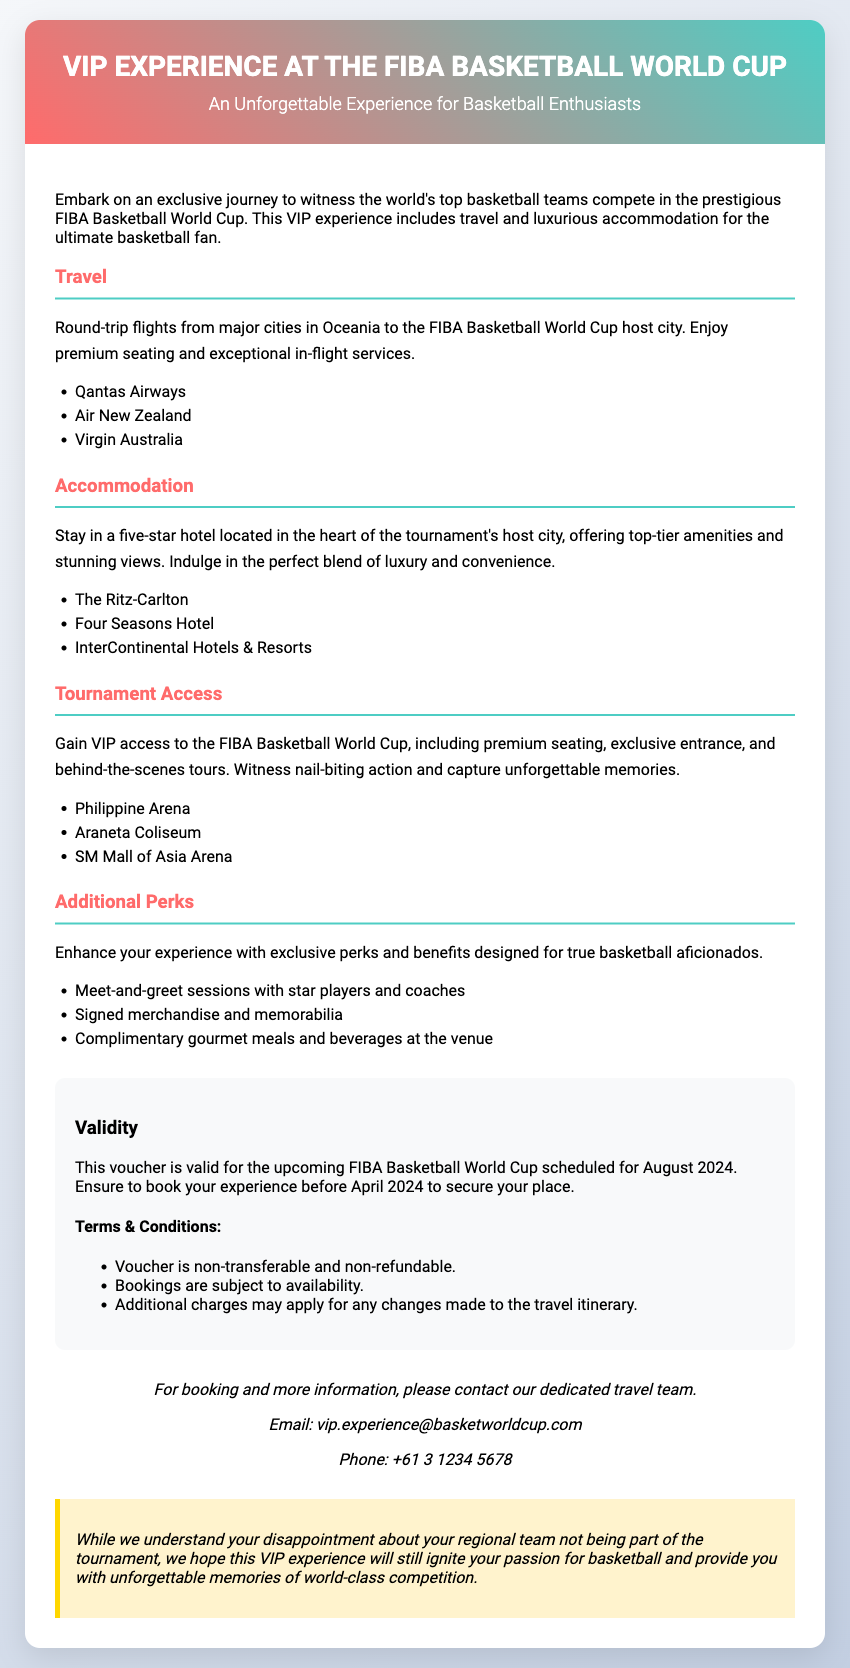what is the title of the VIP experience? The title of the VIP experience is prominently displayed at the top of the document.
Answer: VIP Experience at the FIBA Basketball World Cup what is the host city for the FIBA Basketball World Cup? The document lists several arenas, implying they are in the host city for the tournament.
Answer: Not specified how many airlines are mentioned for travel? The travel section lists a total of three airlines providing round-trip flights.
Answer: Three what month must bookings be made by to secure a place? The validity section specifies the deadline for bookings.
Answer: April 2024 what is included in the Additional Perks section? The Additional Perks section lists three enhancements for the experience.
Answer: Meet-and-greet sessions, signed merchandise, complimentary gourmet meals who should be contacted for booking information? The contact section provides a specific email address for inquiries.
Answer: vip.experience@basketworldcup.com what is the validity duration of the voucher? The validity section clarifies when the voucher can be used.
Answer: August 2024 what type of accommodation is included in the experience? The accommodation section describes the type of hotel provided to guests.
Answer: Five-star hotel 